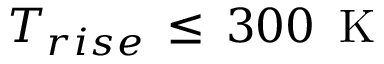<formula> <loc_0><loc_0><loc_500><loc_500>T _ { r i s e } \, \leq \, 3 0 0 \, K</formula> 